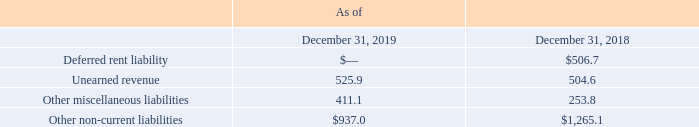AMERICAN TOWER CORPORATION AND SUBSIDIARIES NOTES TO CONSOLIDATED FINANCIAL STATEMENTS (Tabular amounts in millions, unless otherwise disclosed)
10. OTHER NON-CURRENT LIABILITIES
Other non-current liabilities consisted of the following:
The reduction in Deferred rent liability is a result of the Company’s adoption of the new lease accounting standard.
Why was there a reduction in the company's deferred rent liability? The company’s adoption of the new lease accounting standard. What was the deferred rent liability in 2018?
Answer scale should be: million. $506.7. What was the Unearned revenue in 2019?
Answer scale should be: million. 525.9. What was the change in unearned revenue between 2018 and 2019?
Answer scale should be: million. 525.9-504.6
Answer: 21.3. How many of the non-current liabilities components in 2018 were above $500 million?
Answer scale should be: million. Deferred rent liability##Unearned revenue
Answer: 2. What was the percentage change between other non-current liabilities between 2018 and 2019?
Answer scale should be: percent. ($937.0-$1,265.1)/$1,265.1
Answer: -25.93. 